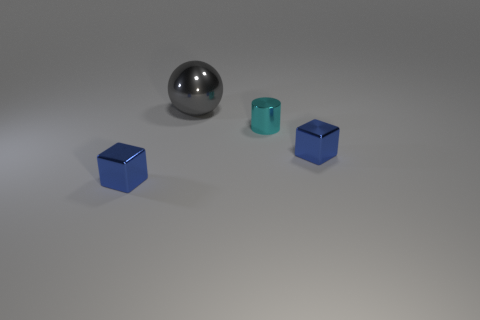How many blocks are small brown rubber objects or cyan objects?
Your answer should be very brief. 0. What number of objects are either cylinders or metallic objects that are in front of the cyan shiny cylinder?
Provide a succinct answer. 3. Is there a purple metallic ball?
Offer a terse response. No. What number of metal objects have the same color as the cylinder?
Ensure brevity in your answer.  0. There is a blue metal thing on the right side of the small metallic thing to the left of the big gray shiny object; what size is it?
Offer a terse response. Small. Are there any other gray cylinders that have the same material as the tiny cylinder?
Ensure brevity in your answer.  No. There is a tiny metal thing left of the cyan shiny cylinder; does it have the same color as the thing right of the small cyan object?
Make the answer very short. Yes. There is a shiny cube that is to the left of the big object; are there any cyan shiny things in front of it?
Your response must be concise. No. Do the large metallic thing that is behind the cyan cylinder and the tiny blue object left of the big gray sphere have the same shape?
Keep it short and to the point. No. Are the tiny blue object on the right side of the gray metal thing and the cyan cylinder that is in front of the large gray object made of the same material?
Ensure brevity in your answer.  Yes. 